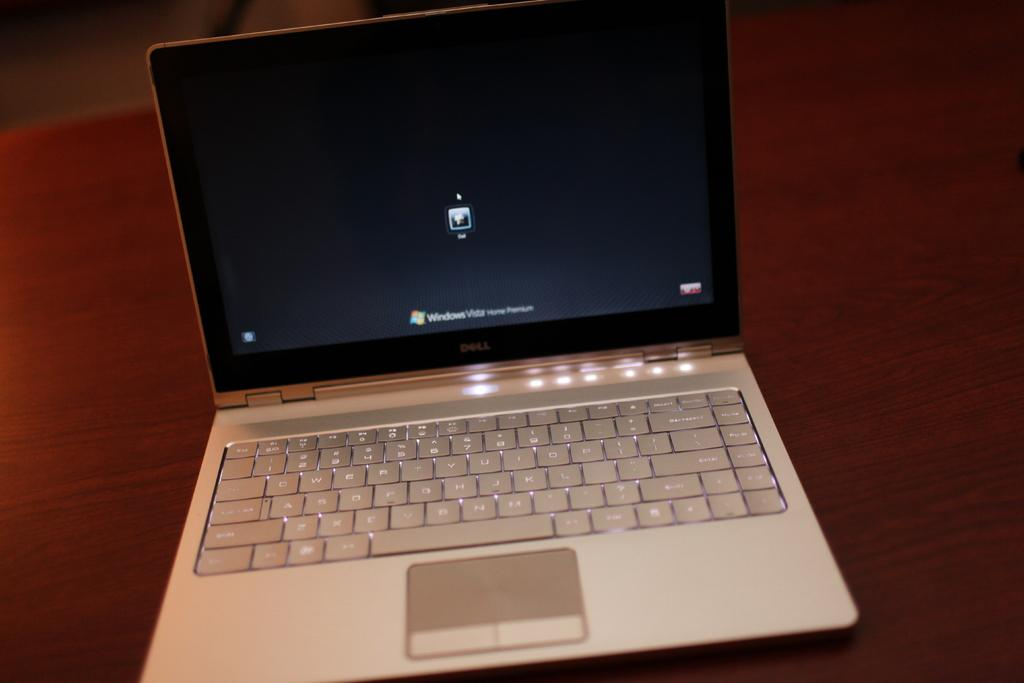<image>
Relay a brief, clear account of the picture shown. a computer with Windows on the bottom of the screen 